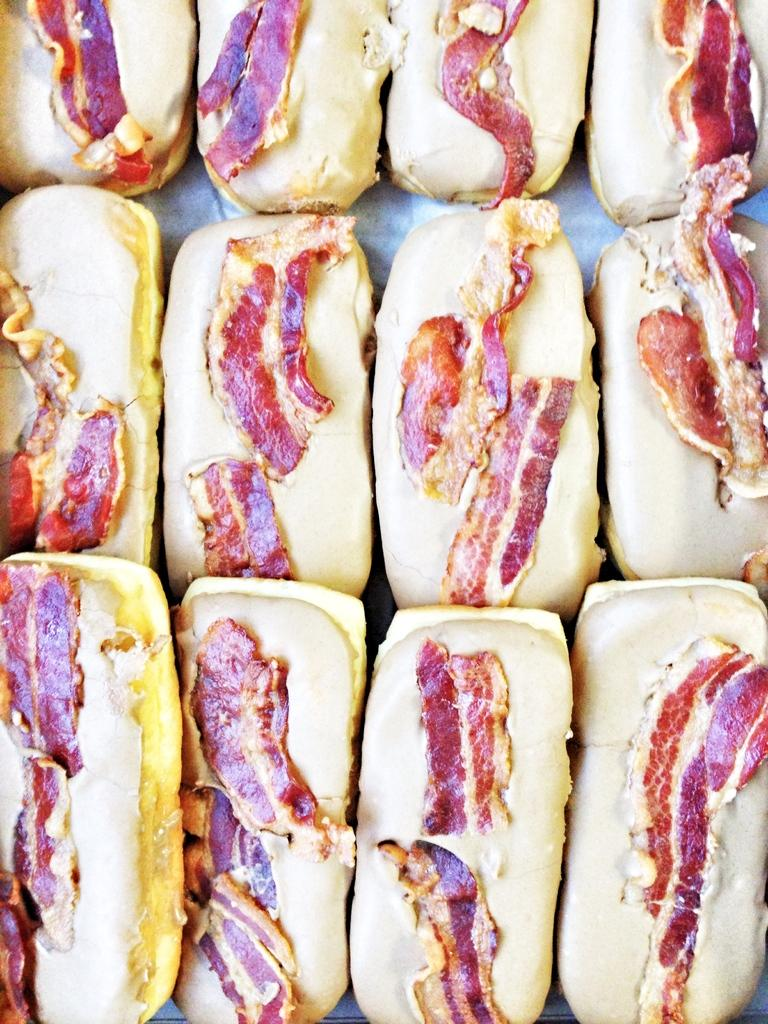What types of food items can be seen in the image? There are food items in the image, but the specific types are not mentioned. Can you describe any specific ingredients on the food items? Yes, there are meat slices on the food items. What part of the brain can be seen on the food items in the image? There is no brain or any part of it present on the food items in the image. Can you tell me how many porters are carrying the food items in the image? There is no indication of porters or any other people carrying the food items in the image. 